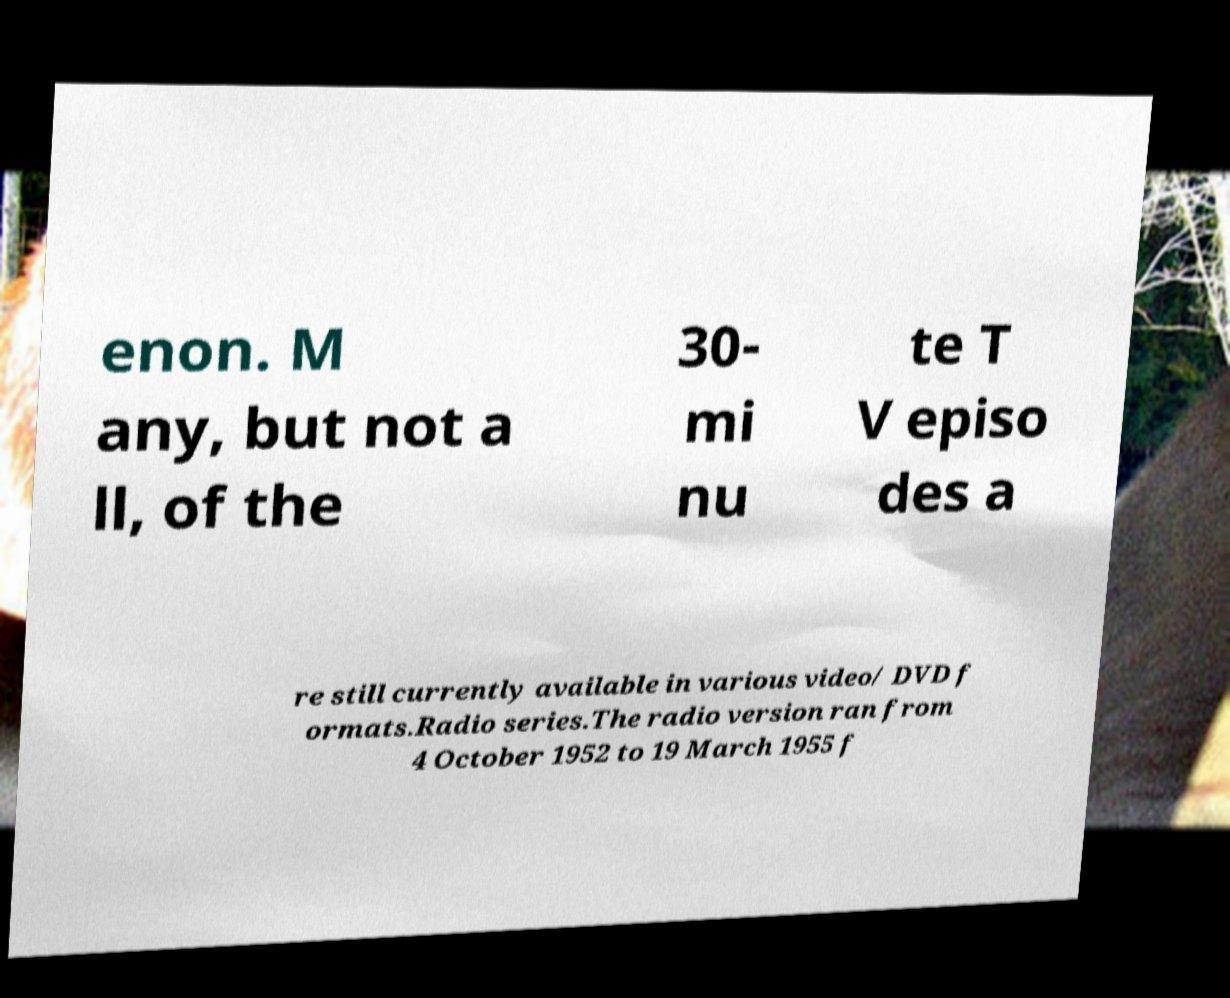Could you assist in decoding the text presented in this image and type it out clearly? enon. M any, but not a ll, of the 30- mi nu te T V episo des a re still currently available in various video/ DVD f ormats.Radio series.The radio version ran from 4 October 1952 to 19 March 1955 f 